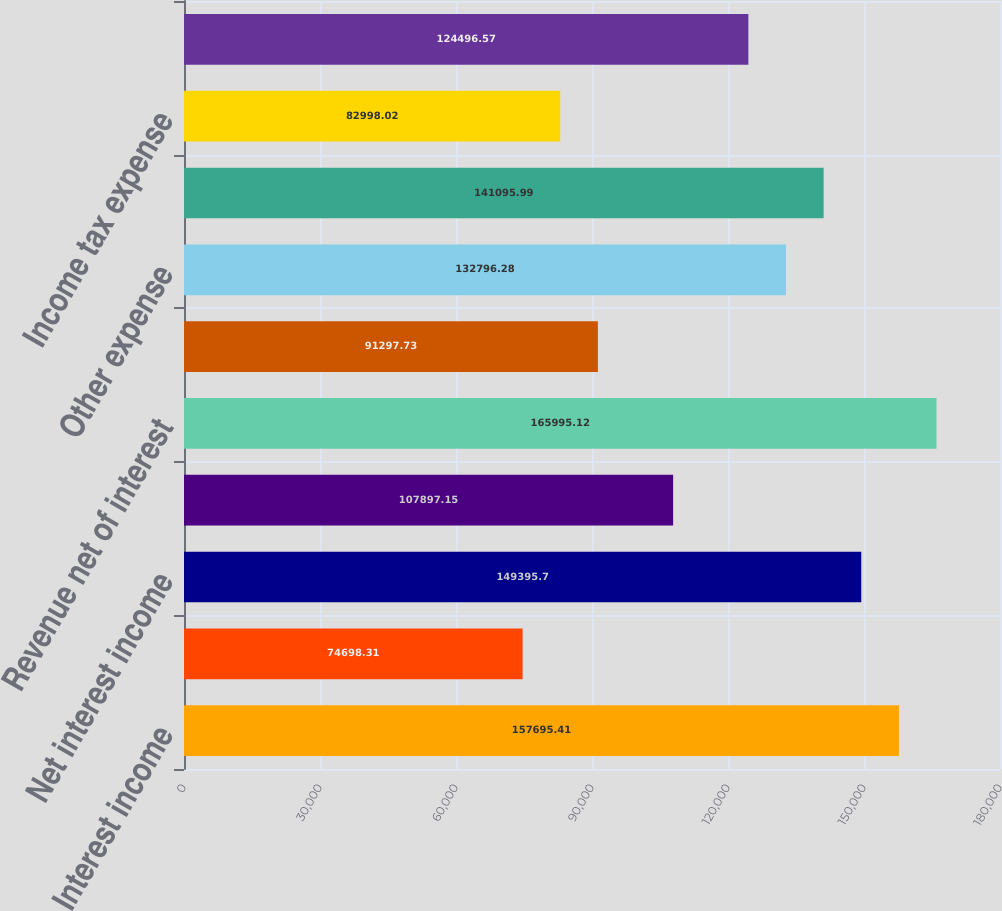Convert chart to OTSL. <chart><loc_0><loc_0><loc_500><loc_500><bar_chart><fcel>Interest income<fcel>Interest expense<fcel>Net interest income<fcel>Other income<fcel>Revenue net of interest<fcel>Provision for loan losses<fcel>Other expense<fcel>Income before income tax<fcel>Income tax expense<fcel>Net income<nl><fcel>157695<fcel>74698.3<fcel>149396<fcel>107897<fcel>165995<fcel>91297.7<fcel>132796<fcel>141096<fcel>82998<fcel>124497<nl></chart> 